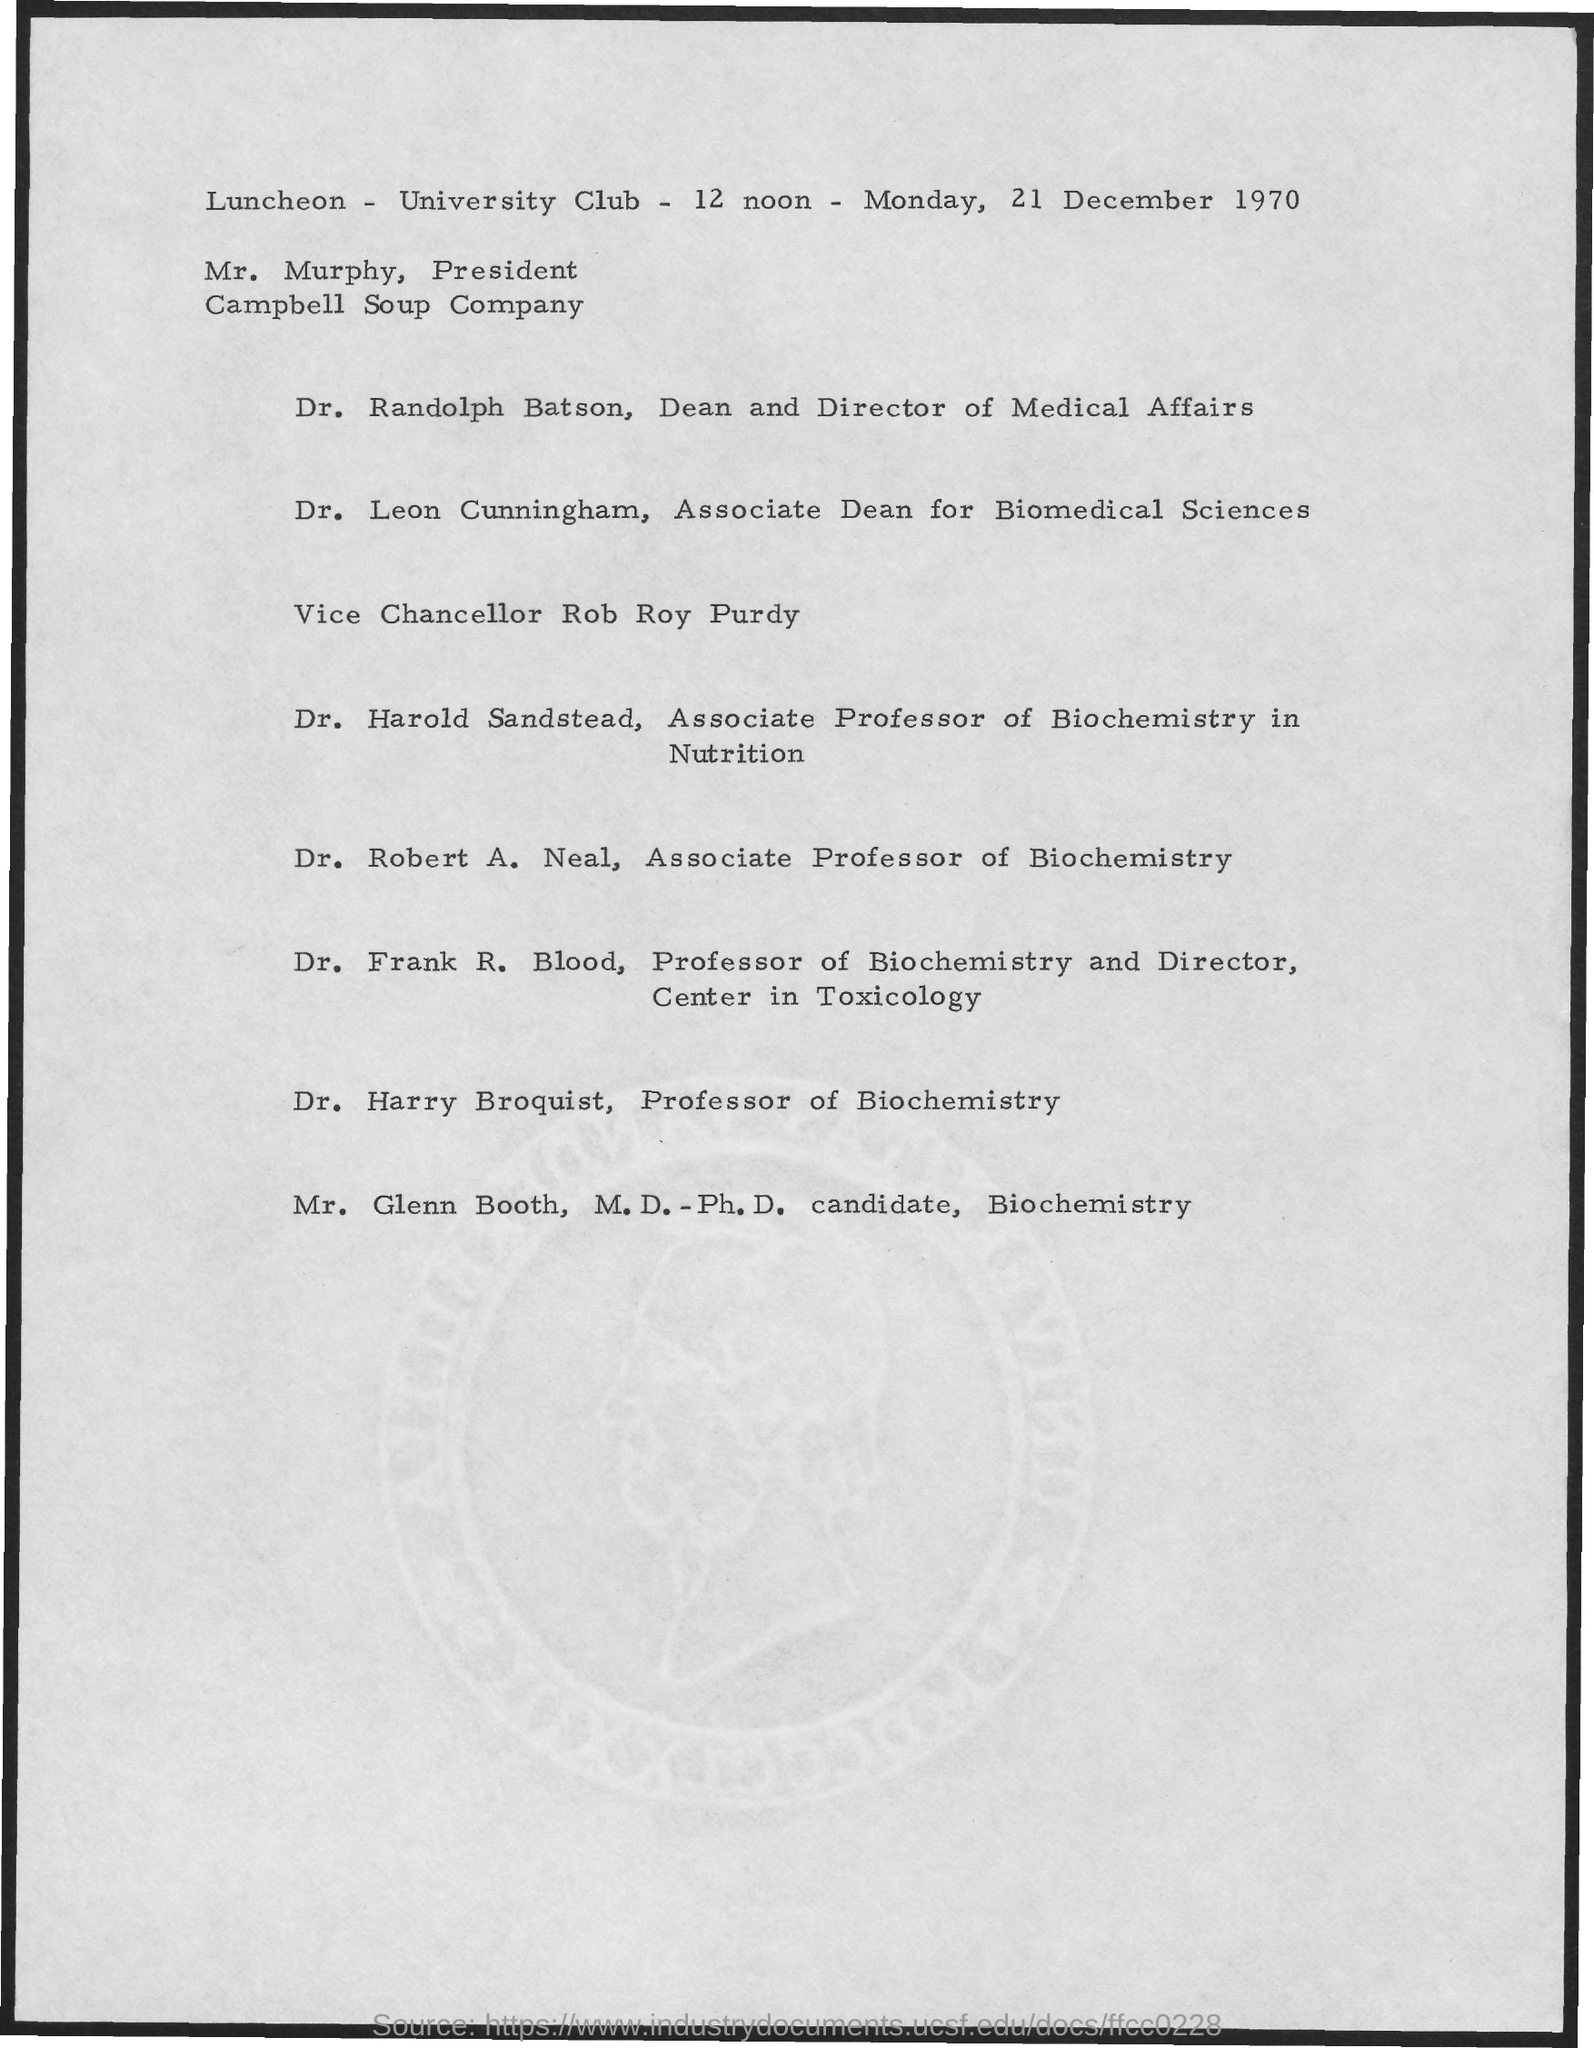Who is the Dean and Director of Medical Affairs?
Ensure brevity in your answer.  Dr. Randolph Batson. What is the date mentioned?
Give a very brief answer. Monday, 21 December 1970. 